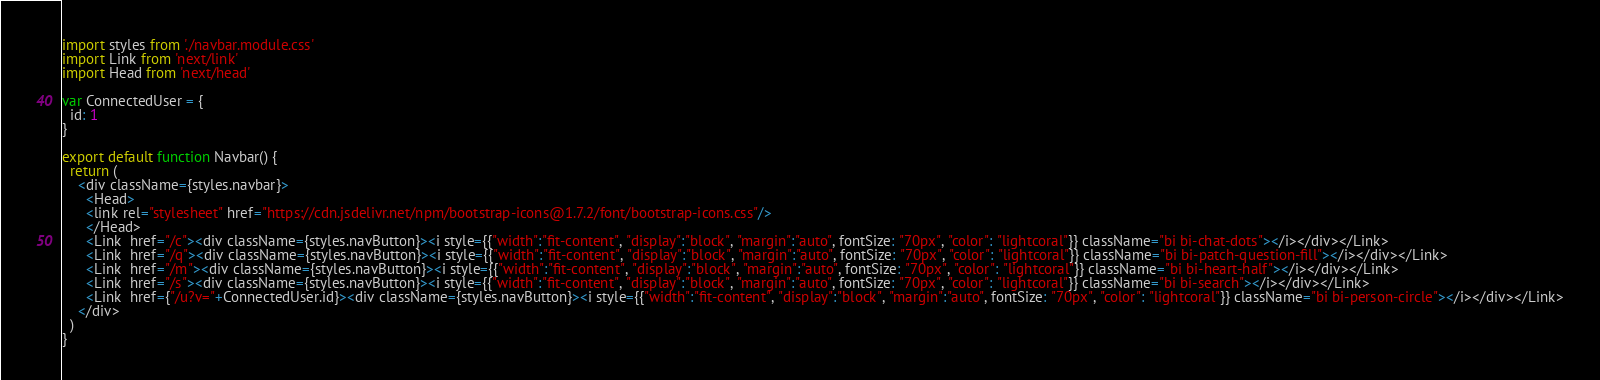<code> <loc_0><loc_0><loc_500><loc_500><_JavaScript_>import styles from './navbar.module.css'
import Link from 'next/link'
import Head from 'next/head'

var ConnectedUser = {
  id: 1
}

export default function Navbar() {
  return (
    <div className={styles.navbar}>
      <Head>
      <link rel="stylesheet" href="https://cdn.jsdelivr.net/npm/bootstrap-icons@1.7.2/font/bootstrap-icons.css"/>
      </Head>
      <Link  href="/c"><div className={styles.navButton}><i style={{"width":"fit-content", "display":"block", "margin":"auto", fontSize: "70px", "color": "lightcoral"}} className="bi bi-chat-dots"></i></div></Link>
      <Link  href="/q"><div className={styles.navButton}><i style={{"width":"fit-content", "display":"block", "margin":"auto", fontSize: "70px", "color": "lightcoral"}} className="bi bi-patch-question-fill"></i></div></Link>
      <Link  href="/m"><div className={styles.navButton}><i style={{"width":"fit-content", "display":"block", "margin":"auto", fontSize: "70px", "color": "lightcoral"}} className="bi bi-heart-half"></i></div></Link>
      <Link  href="/s"><div className={styles.navButton}><i style={{"width":"fit-content", "display":"block", "margin":"auto", fontSize: "70px", "color": "lightcoral"}} className="bi bi-search"></i></div></Link>
      <Link  href={"/u?v="+ConnectedUser.id}><div className={styles.navButton}><i style={{"width":"fit-content", "display":"block", "margin":"auto", fontSize: "70px", "color": "lightcoral"}} className="bi bi-person-circle"></i></div></Link>
    </div>
  )
}

</code> 